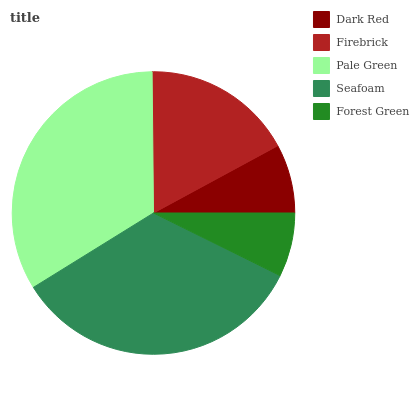Is Forest Green the minimum?
Answer yes or no. Yes. Is Seafoam the maximum?
Answer yes or no. Yes. Is Firebrick the minimum?
Answer yes or no. No. Is Firebrick the maximum?
Answer yes or no. No. Is Firebrick greater than Dark Red?
Answer yes or no. Yes. Is Dark Red less than Firebrick?
Answer yes or no. Yes. Is Dark Red greater than Firebrick?
Answer yes or no. No. Is Firebrick less than Dark Red?
Answer yes or no. No. Is Firebrick the high median?
Answer yes or no. Yes. Is Firebrick the low median?
Answer yes or no. Yes. Is Forest Green the high median?
Answer yes or no. No. Is Seafoam the low median?
Answer yes or no. No. 